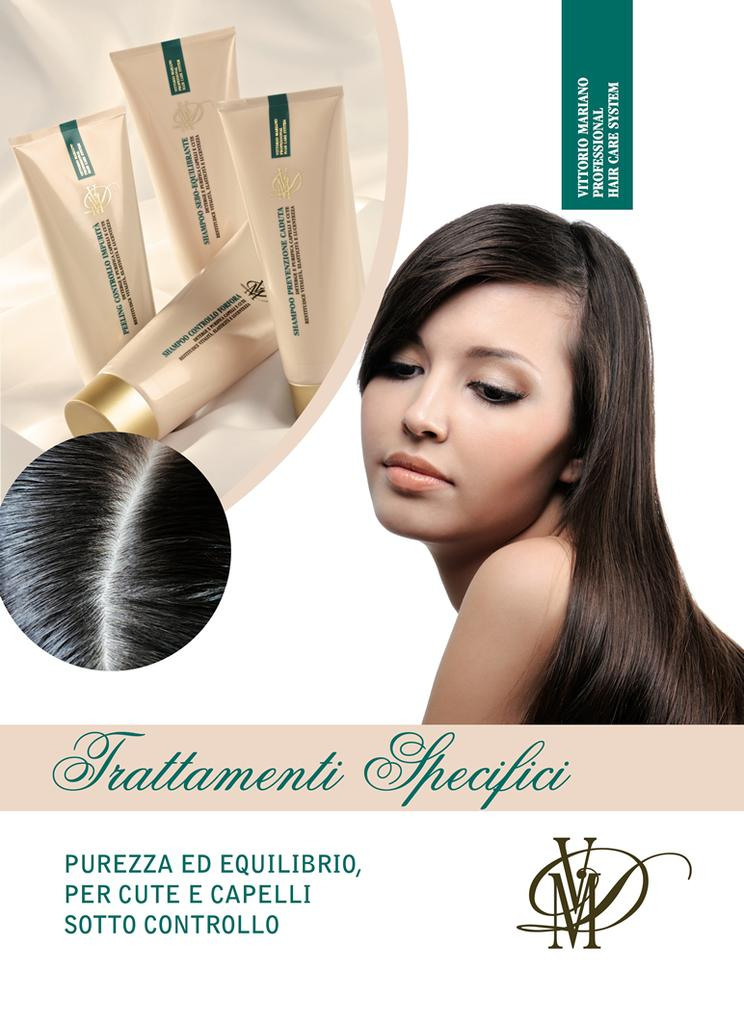<image>
Offer a succinct explanation of the picture presented. An Italian makeup that is called Frattamenti Specifici 